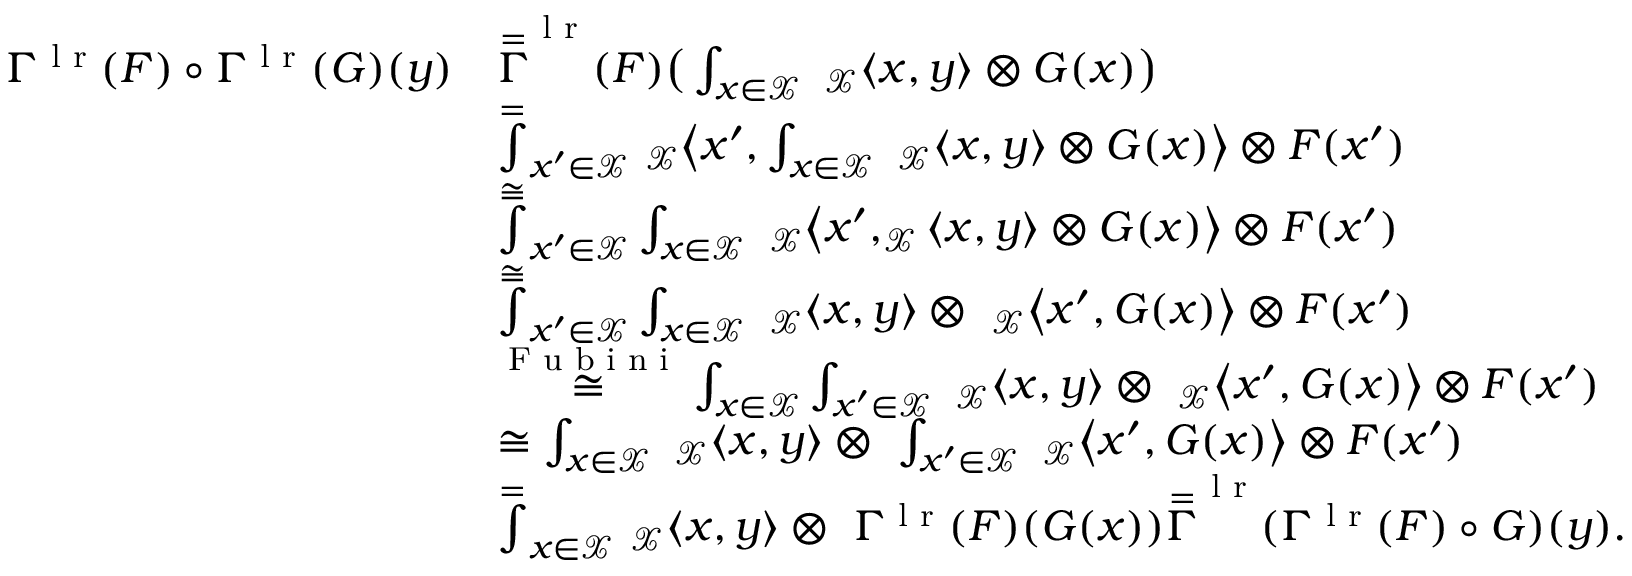Convert formula to latex. <formula><loc_0><loc_0><loc_500><loc_500>\begin{array} { r l } { \Gamma ^ { l r } ( F ) \circ \Gamma ^ { l r } ( G ) ( y ) } & { \overset { = } \Gamma ^ { l r } ( F ) \left ( \int _ { x \in \mathcal { X } } \ _ { \mathcal { X } } \langle x , y \rangle \otimes G ( x ) \right ) } \\ & { \overset { = } \int _ { x ^ { \prime } \in \mathcal { X } } \ _ { \mathcal { X } } \left \langle x ^ { \prime } , \int _ { x \in \mathcal { X } } \ _ { \mathcal { X } } \langle x , y \rangle \otimes G ( x ) \right \rangle \otimes F ( x ^ { \prime } ) } \\ & { \overset { \cong } \int _ { x ^ { \prime } \in \mathcal { X } } \int _ { x \in \mathcal { X } } \ _ { \mathcal { X } } \left \langle x ^ { \prime } , _ { \mathcal { X } } \langle x , y \rangle \otimes G ( x ) \right \rangle \otimes F ( x ^ { \prime } ) } \\ & { \overset { \cong } \int _ { x ^ { \prime } \in \mathcal { X } } \int _ { x \in \mathcal { X } } \ _ { \mathcal { X } } \langle x , y \rangle \otimes \ _ { \mathcal { X } } \left \langle x ^ { \prime } , G ( x ) \right \rangle \otimes F ( x ^ { \prime } ) } \\ & { \overset { F u b i n i } { \cong } \int _ { x \in \mathcal { X } } \int _ { x ^ { \prime } \in \mathcal { X } } \ _ { \mathcal { X } } \langle x , y \rangle \otimes \ _ { \mathcal { X } } \left \langle x ^ { \prime } , G ( x ) \right \rangle \otimes F ( x ^ { \prime } ) } \\ & { \cong \int _ { x \in \mathcal { X } } \ _ { \mathcal { X } } \langle x , y \rangle \otimes \ \int _ { x ^ { \prime } \in \mathcal { X } } \ _ { \mathcal { X } } \left \langle x ^ { \prime } , G ( x ) \right \rangle \otimes F ( x ^ { \prime } ) } \\ & { \overset { = } \int _ { x \in \mathcal { X } } \ _ { \mathcal { X } } \langle x , y \rangle \otimes \ \Gamma ^ { l r } ( F ) ( G ( x ) ) \overset { = } \Gamma ^ { l r } ( \Gamma ^ { l r } ( F ) \circ G ) ( y ) . } \end{array}</formula> 